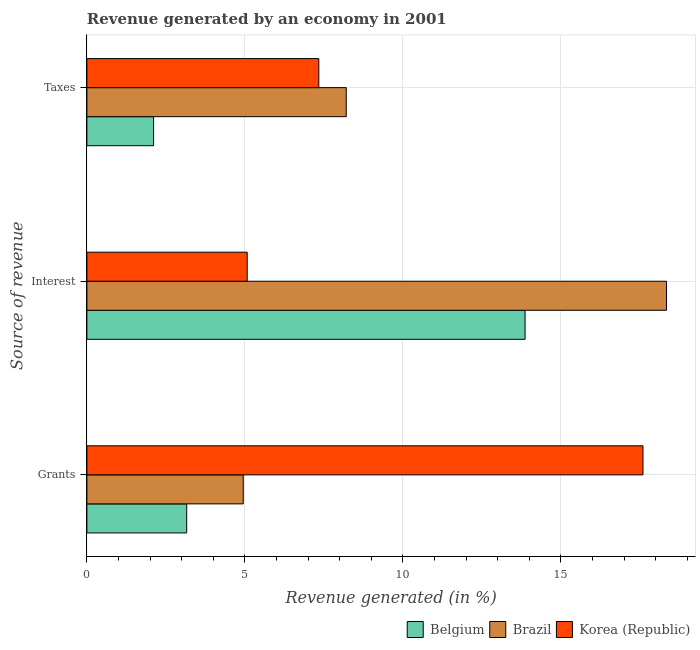How many different coloured bars are there?
Ensure brevity in your answer.  3. How many groups of bars are there?
Your answer should be very brief. 3. Are the number of bars per tick equal to the number of legend labels?
Offer a terse response. Yes. What is the label of the 1st group of bars from the top?
Make the answer very short. Taxes. What is the percentage of revenue generated by interest in Belgium?
Give a very brief answer. 13.87. Across all countries, what is the maximum percentage of revenue generated by taxes?
Provide a succinct answer. 8.21. Across all countries, what is the minimum percentage of revenue generated by grants?
Offer a very short reply. 3.16. What is the total percentage of revenue generated by grants in the graph?
Your response must be concise. 25.71. What is the difference between the percentage of revenue generated by taxes in Korea (Republic) and that in Belgium?
Your response must be concise. 5.23. What is the difference between the percentage of revenue generated by grants in Korea (Republic) and the percentage of revenue generated by interest in Brazil?
Keep it short and to the point. -0.74. What is the average percentage of revenue generated by interest per country?
Give a very brief answer. 12.43. What is the difference between the percentage of revenue generated by taxes and percentage of revenue generated by grants in Brazil?
Offer a terse response. 3.26. What is the ratio of the percentage of revenue generated by interest in Belgium to that in Korea (Republic)?
Offer a very short reply. 2.73. What is the difference between the highest and the second highest percentage of revenue generated by taxes?
Provide a succinct answer. 0.87. What is the difference between the highest and the lowest percentage of revenue generated by interest?
Offer a very short reply. 13.27. Is the sum of the percentage of revenue generated by grants in Brazil and Korea (Republic) greater than the maximum percentage of revenue generated by taxes across all countries?
Your response must be concise. Yes. What does the 1st bar from the bottom in Interest represents?
Make the answer very short. Belgium. Is it the case that in every country, the sum of the percentage of revenue generated by grants and percentage of revenue generated by interest is greater than the percentage of revenue generated by taxes?
Offer a terse response. Yes. Are all the bars in the graph horizontal?
Offer a terse response. Yes. How many countries are there in the graph?
Your answer should be very brief. 3. What is the difference between two consecutive major ticks on the X-axis?
Keep it short and to the point. 5. Are the values on the major ticks of X-axis written in scientific E-notation?
Provide a succinct answer. No. How many legend labels are there?
Give a very brief answer. 3. How are the legend labels stacked?
Offer a very short reply. Horizontal. What is the title of the graph?
Give a very brief answer. Revenue generated by an economy in 2001. Does "Angola" appear as one of the legend labels in the graph?
Keep it short and to the point. No. What is the label or title of the X-axis?
Provide a short and direct response. Revenue generated (in %). What is the label or title of the Y-axis?
Your answer should be compact. Source of revenue. What is the Revenue generated (in %) in Belgium in Grants?
Your response must be concise. 3.16. What is the Revenue generated (in %) in Brazil in Grants?
Your answer should be compact. 4.95. What is the Revenue generated (in %) in Korea (Republic) in Grants?
Ensure brevity in your answer.  17.6. What is the Revenue generated (in %) of Belgium in Interest?
Provide a short and direct response. 13.87. What is the Revenue generated (in %) of Brazil in Interest?
Give a very brief answer. 18.35. What is the Revenue generated (in %) in Korea (Republic) in Interest?
Your answer should be very brief. 5.07. What is the Revenue generated (in %) in Belgium in Taxes?
Offer a very short reply. 2.11. What is the Revenue generated (in %) of Brazil in Taxes?
Your answer should be compact. 8.21. What is the Revenue generated (in %) in Korea (Republic) in Taxes?
Make the answer very short. 7.34. Across all Source of revenue, what is the maximum Revenue generated (in %) in Belgium?
Your answer should be very brief. 13.87. Across all Source of revenue, what is the maximum Revenue generated (in %) in Brazil?
Your response must be concise. 18.35. Across all Source of revenue, what is the maximum Revenue generated (in %) in Korea (Republic)?
Keep it short and to the point. 17.6. Across all Source of revenue, what is the minimum Revenue generated (in %) of Belgium?
Your response must be concise. 2.11. Across all Source of revenue, what is the minimum Revenue generated (in %) of Brazil?
Offer a very short reply. 4.95. Across all Source of revenue, what is the minimum Revenue generated (in %) in Korea (Republic)?
Keep it short and to the point. 5.07. What is the total Revenue generated (in %) in Belgium in the graph?
Keep it short and to the point. 19.14. What is the total Revenue generated (in %) in Brazil in the graph?
Your answer should be very brief. 31.5. What is the total Revenue generated (in %) in Korea (Republic) in the graph?
Provide a short and direct response. 30.02. What is the difference between the Revenue generated (in %) of Belgium in Grants and that in Interest?
Offer a very short reply. -10.71. What is the difference between the Revenue generated (in %) of Brazil in Grants and that in Interest?
Offer a very short reply. -13.4. What is the difference between the Revenue generated (in %) of Korea (Republic) in Grants and that in Interest?
Give a very brief answer. 12.53. What is the difference between the Revenue generated (in %) of Belgium in Grants and that in Taxes?
Provide a short and direct response. 1.05. What is the difference between the Revenue generated (in %) in Brazil in Grants and that in Taxes?
Ensure brevity in your answer.  -3.26. What is the difference between the Revenue generated (in %) in Korea (Republic) in Grants and that in Taxes?
Keep it short and to the point. 10.26. What is the difference between the Revenue generated (in %) of Belgium in Interest and that in Taxes?
Keep it short and to the point. 11.76. What is the difference between the Revenue generated (in %) of Brazil in Interest and that in Taxes?
Offer a terse response. 10.14. What is the difference between the Revenue generated (in %) in Korea (Republic) in Interest and that in Taxes?
Your response must be concise. -2.27. What is the difference between the Revenue generated (in %) in Belgium in Grants and the Revenue generated (in %) in Brazil in Interest?
Your response must be concise. -15.19. What is the difference between the Revenue generated (in %) in Belgium in Grants and the Revenue generated (in %) in Korea (Republic) in Interest?
Offer a terse response. -1.91. What is the difference between the Revenue generated (in %) of Brazil in Grants and the Revenue generated (in %) of Korea (Republic) in Interest?
Offer a terse response. -0.12. What is the difference between the Revenue generated (in %) of Belgium in Grants and the Revenue generated (in %) of Brazil in Taxes?
Offer a very short reply. -5.05. What is the difference between the Revenue generated (in %) of Belgium in Grants and the Revenue generated (in %) of Korea (Republic) in Taxes?
Give a very brief answer. -4.18. What is the difference between the Revenue generated (in %) in Brazil in Grants and the Revenue generated (in %) in Korea (Republic) in Taxes?
Your response must be concise. -2.39. What is the difference between the Revenue generated (in %) in Belgium in Interest and the Revenue generated (in %) in Brazil in Taxes?
Provide a succinct answer. 5.66. What is the difference between the Revenue generated (in %) in Belgium in Interest and the Revenue generated (in %) in Korea (Republic) in Taxes?
Offer a very short reply. 6.53. What is the difference between the Revenue generated (in %) of Brazil in Interest and the Revenue generated (in %) of Korea (Republic) in Taxes?
Make the answer very short. 11. What is the average Revenue generated (in %) of Belgium per Source of revenue?
Make the answer very short. 6.38. What is the average Revenue generated (in %) of Brazil per Source of revenue?
Your answer should be compact. 10.5. What is the average Revenue generated (in %) of Korea (Republic) per Source of revenue?
Make the answer very short. 10.01. What is the difference between the Revenue generated (in %) in Belgium and Revenue generated (in %) in Brazil in Grants?
Your answer should be compact. -1.79. What is the difference between the Revenue generated (in %) in Belgium and Revenue generated (in %) in Korea (Republic) in Grants?
Offer a terse response. -14.44. What is the difference between the Revenue generated (in %) in Brazil and Revenue generated (in %) in Korea (Republic) in Grants?
Offer a terse response. -12.65. What is the difference between the Revenue generated (in %) in Belgium and Revenue generated (in %) in Brazil in Interest?
Give a very brief answer. -4.48. What is the difference between the Revenue generated (in %) in Belgium and Revenue generated (in %) in Korea (Republic) in Interest?
Ensure brevity in your answer.  8.8. What is the difference between the Revenue generated (in %) of Brazil and Revenue generated (in %) of Korea (Republic) in Interest?
Ensure brevity in your answer.  13.27. What is the difference between the Revenue generated (in %) of Belgium and Revenue generated (in %) of Brazil in Taxes?
Offer a terse response. -6.1. What is the difference between the Revenue generated (in %) of Belgium and Revenue generated (in %) of Korea (Republic) in Taxes?
Make the answer very short. -5.23. What is the difference between the Revenue generated (in %) of Brazil and Revenue generated (in %) of Korea (Republic) in Taxes?
Your answer should be compact. 0.87. What is the ratio of the Revenue generated (in %) of Belgium in Grants to that in Interest?
Your answer should be very brief. 0.23. What is the ratio of the Revenue generated (in %) in Brazil in Grants to that in Interest?
Your answer should be compact. 0.27. What is the ratio of the Revenue generated (in %) in Korea (Republic) in Grants to that in Interest?
Provide a succinct answer. 3.47. What is the ratio of the Revenue generated (in %) of Belgium in Grants to that in Taxes?
Provide a succinct answer. 1.5. What is the ratio of the Revenue generated (in %) in Brazil in Grants to that in Taxes?
Your answer should be compact. 0.6. What is the ratio of the Revenue generated (in %) in Korea (Republic) in Grants to that in Taxes?
Ensure brevity in your answer.  2.4. What is the ratio of the Revenue generated (in %) of Belgium in Interest to that in Taxes?
Provide a succinct answer. 6.57. What is the ratio of the Revenue generated (in %) of Brazil in Interest to that in Taxes?
Offer a very short reply. 2.23. What is the ratio of the Revenue generated (in %) in Korea (Republic) in Interest to that in Taxes?
Keep it short and to the point. 0.69. What is the difference between the highest and the second highest Revenue generated (in %) of Belgium?
Your response must be concise. 10.71. What is the difference between the highest and the second highest Revenue generated (in %) of Brazil?
Give a very brief answer. 10.14. What is the difference between the highest and the second highest Revenue generated (in %) of Korea (Republic)?
Provide a short and direct response. 10.26. What is the difference between the highest and the lowest Revenue generated (in %) in Belgium?
Keep it short and to the point. 11.76. What is the difference between the highest and the lowest Revenue generated (in %) of Brazil?
Keep it short and to the point. 13.4. What is the difference between the highest and the lowest Revenue generated (in %) in Korea (Republic)?
Your answer should be compact. 12.53. 